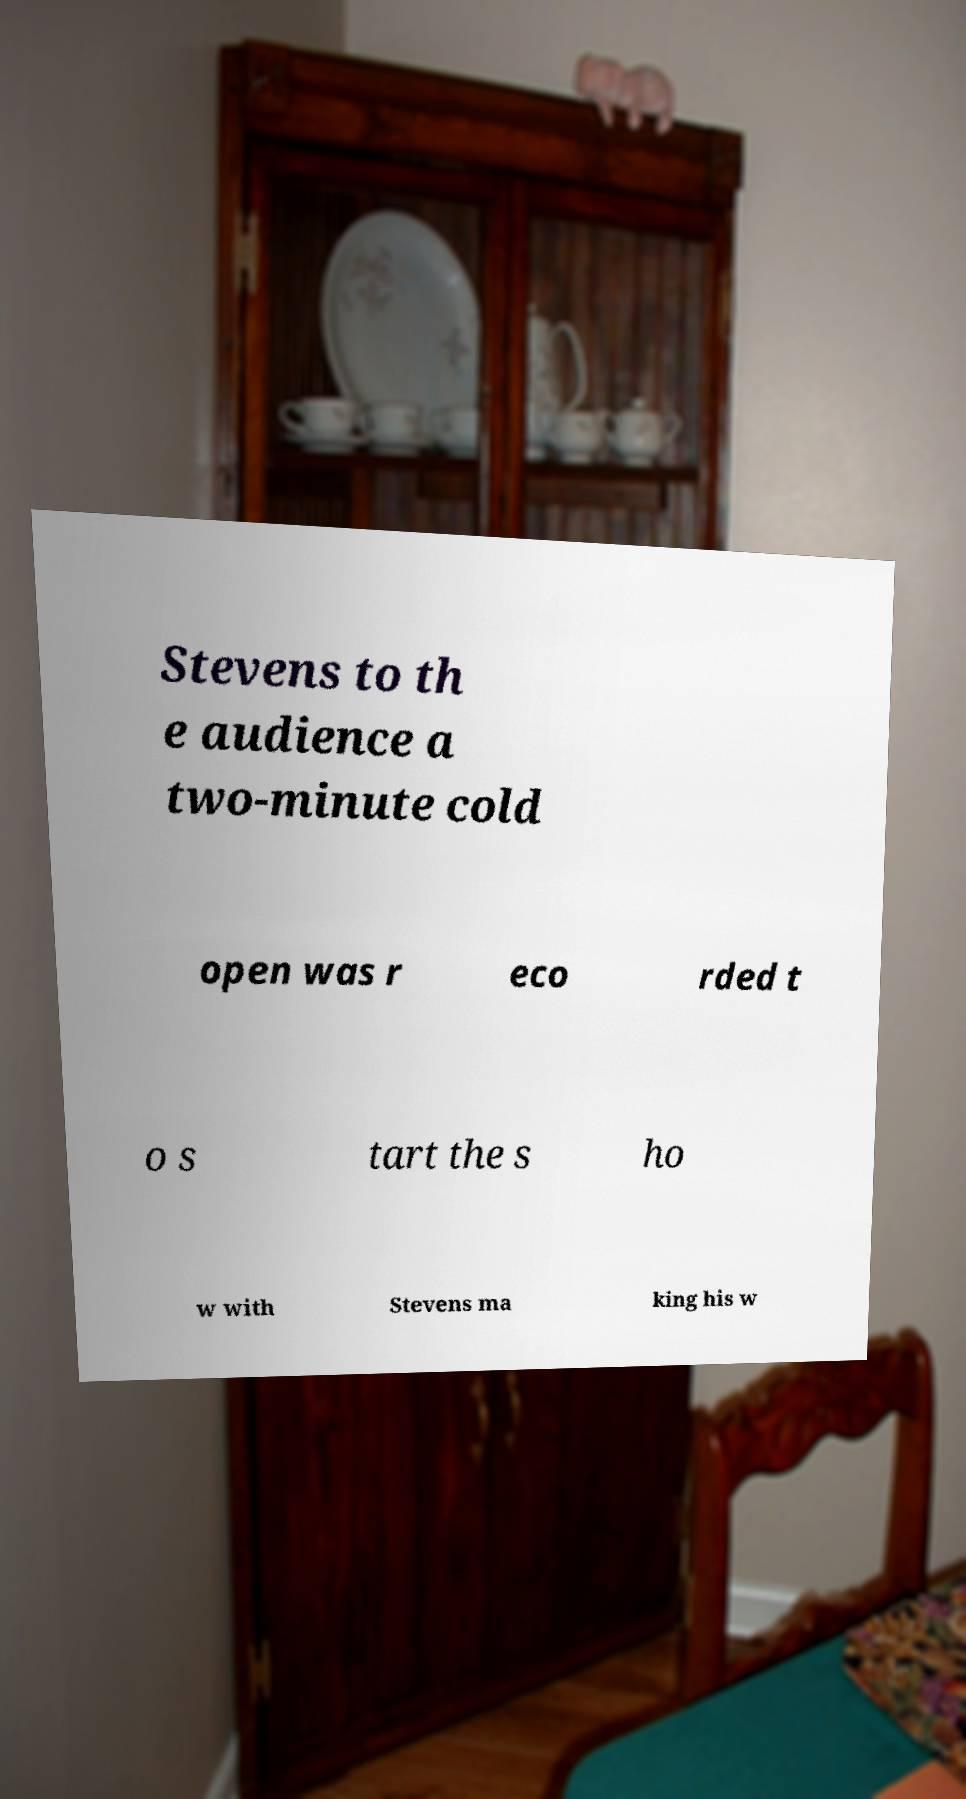Can you read and provide the text displayed in the image?This photo seems to have some interesting text. Can you extract and type it out for me? Stevens to th e audience a two-minute cold open was r eco rded t o s tart the s ho w with Stevens ma king his w 